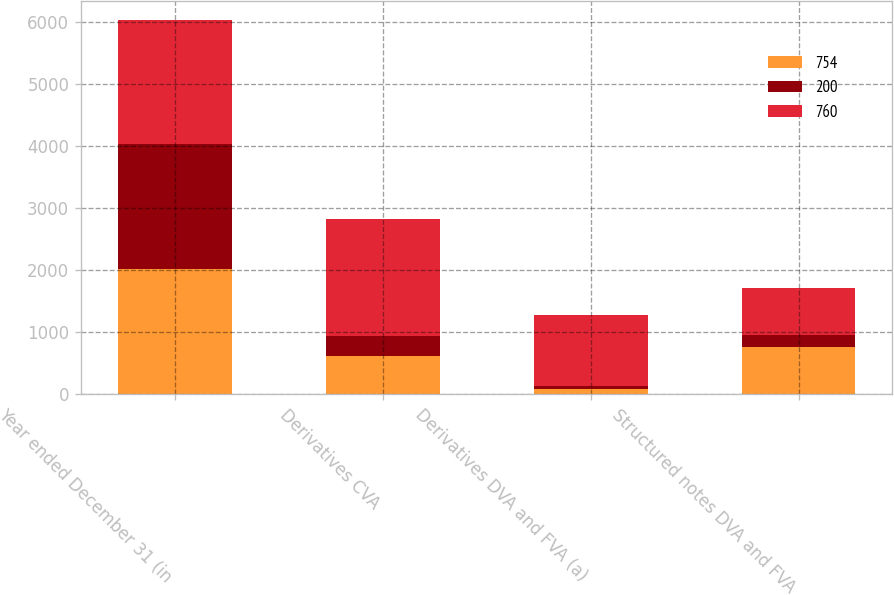Convert chart to OTSL. <chart><loc_0><loc_0><loc_500><loc_500><stacked_bar_chart><ecel><fcel>Year ended December 31 (in<fcel>Derivatives CVA<fcel>Derivatives DVA and FVA (a)<fcel>Structured notes DVA and FVA<nl><fcel>754<fcel>2015<fcel>620<fcel>73<fcel>754<nl><fcel>200<fcel>2014<fcel>322<fcel>58<fcel>200<nl><fcel>760<fcel>2013<fcel>1886<fcel>1152<fcel>760<nl></chart> 